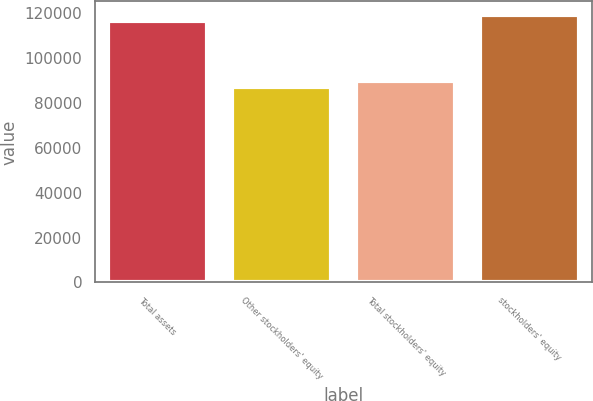Convert chart. <chart><loc_0><loc_0><loc_500><loc_500><bar_chart><fcel>Total assets<fcel>Other stockholders' equity<fcel>Total stockholders' equity<fcel>stockholders' equity<nl><fcel>116361<fcel>86852<fcel>89802.9<fcel>119312<nl></chart> 